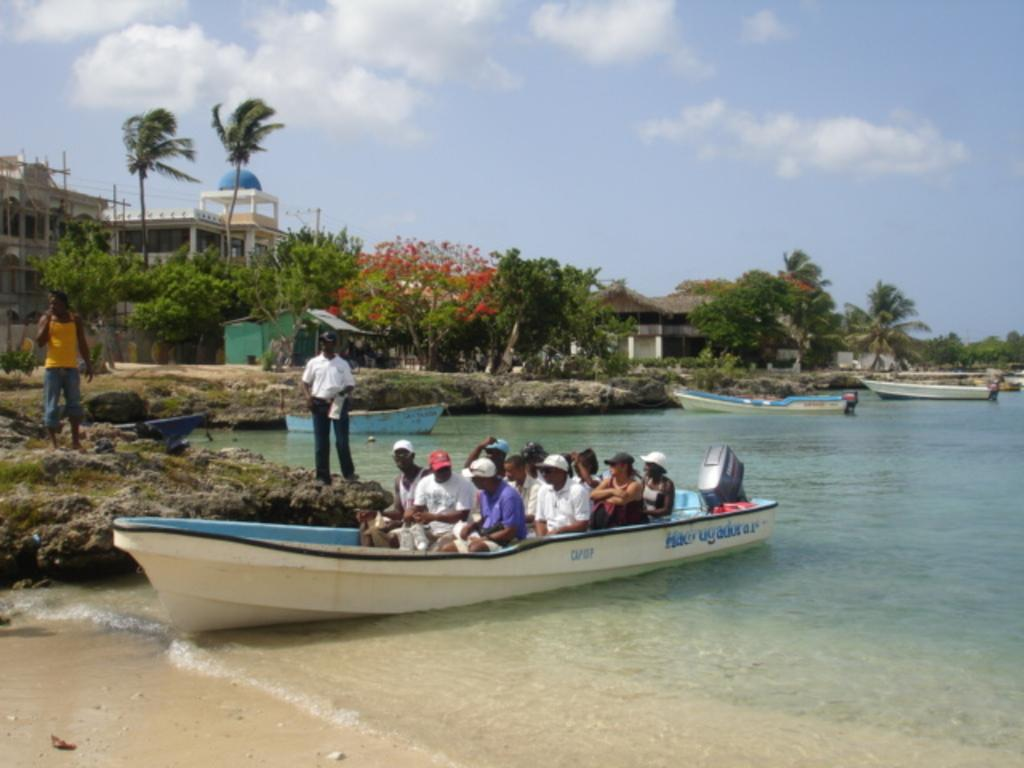How many people are in the image? There are people in the image, but the exact number is not specified. What are some people doing in the image? Some people are in a boat in the water. What is the primary setting of the image? The image features water, boats, grass, trees, plants, buildings, and the sky. What is visible in the sky? Clouds are present in the sky. How do the people in the image plan to turn the boat into a camp? There is no mention of turning the boat into a camp in the image. The image only shows people in a boat and various other elements in the background. 